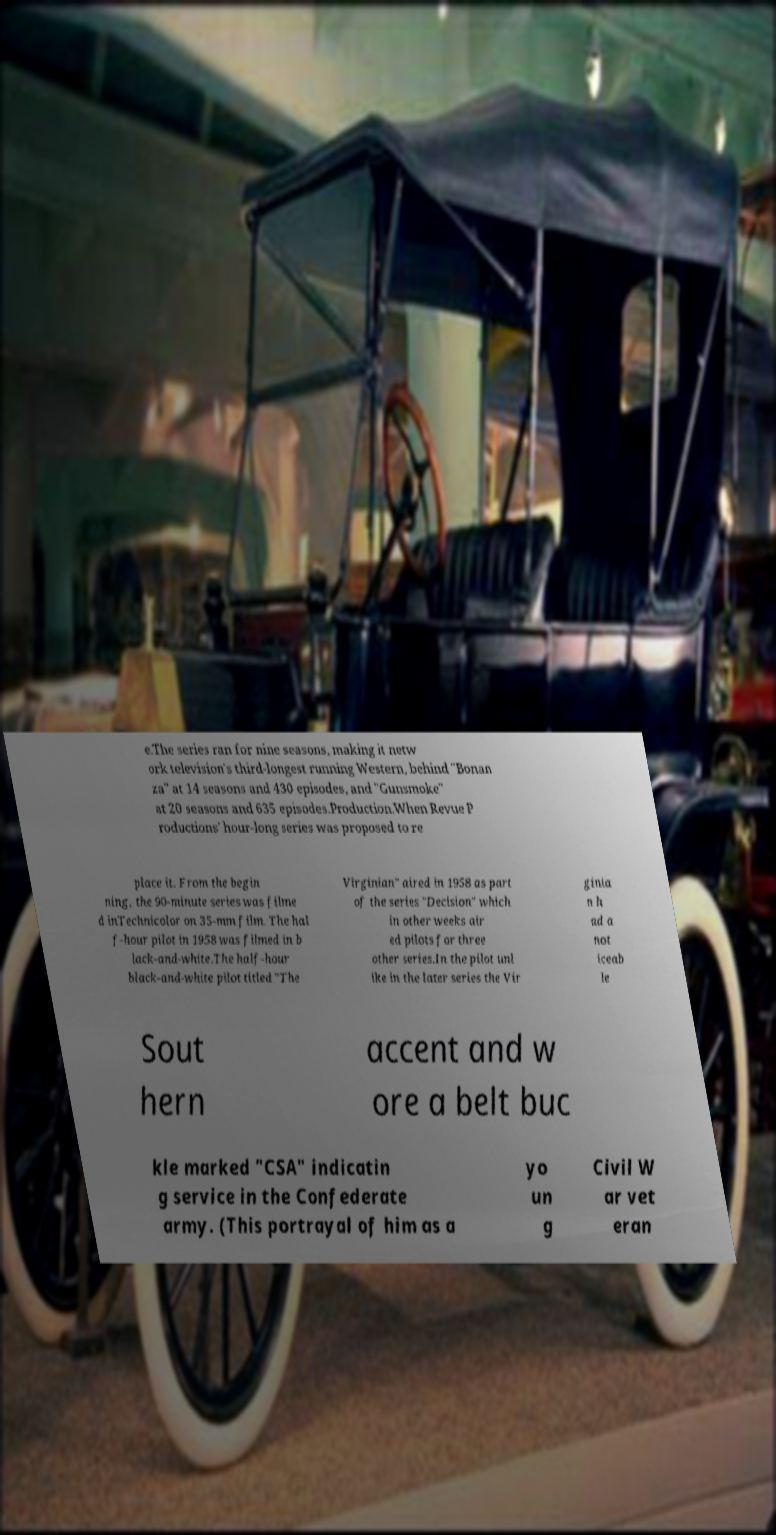Could you extract and type out the text from this image? e.The series ran for nine seasons, making it netw ork television's third-longest running Western, behind "Bonan za" at 14 seasons and 430 episodes, and "Gunsmoke" at 20 seasons and 635 episodes.Production.When Revue P roductions' hour-long series was proposed to re place it. From the begin ning, the 90-minute series was filme d inTechnicolor on 35-mm film. The hal f-hour pilot in 1958 was filmed in b lack-and-white.The half-hour black-and-white pilot titled "The Virginian" aired in 1958 as part of the series "Decision" which in other weeks air ed pilots for three other series.In the pilot unl ike in the later series the Vir ginia n h ad a not iceab le Sout hern accent and w ore a belt buc kle marked "CSA" indicatin g service in the Confederate army. (This portrayal of him as a yo un g Civil W ar vet eran 